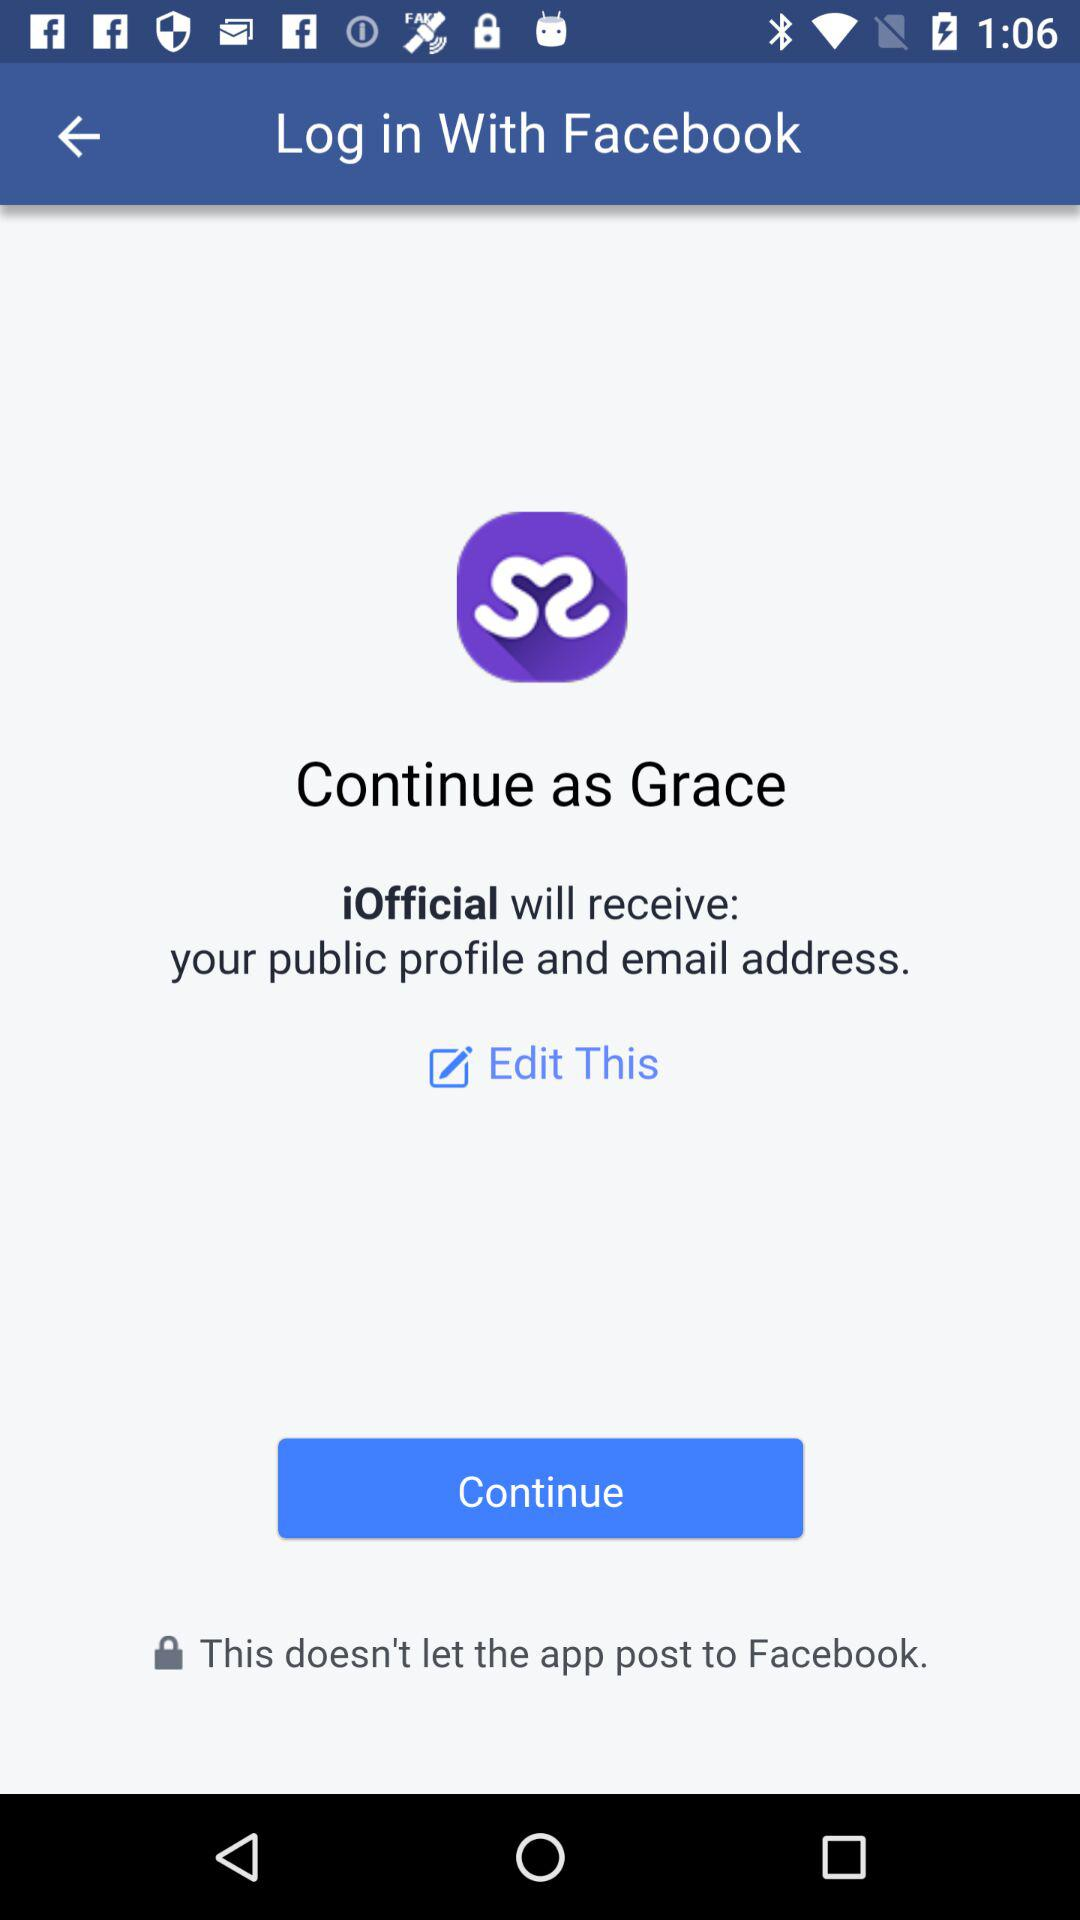What application is asking for permission? The application is "iOfficial". 